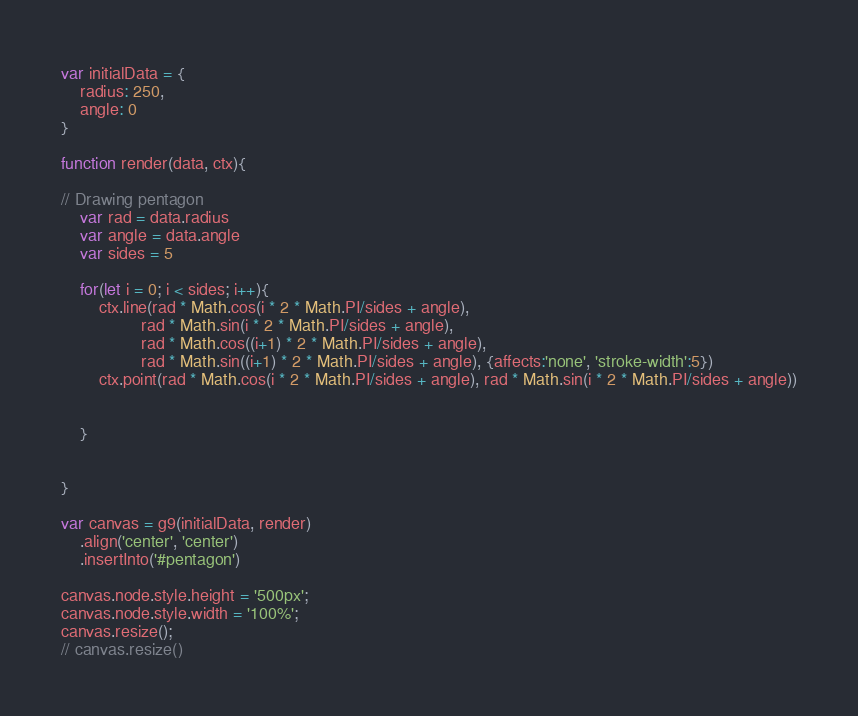Convert code to text. <code><loc_0><loc_0><loc_500><loc_500><_JavaScript_>var initialData = {
    radius: 250,
    angle: 0
}

function render(data, ctx){

// Drawing pentagon
    var rad = data.radius
    var angle = data.angle
    var sides = 5
  
    for(let i = 0; i < sides; i++){
        ctx.line(rad * Math.cos(i * 2 * Math.PI/sides + angle), 
                 rad * Math.sin(i * 2 * Math.PI/sides + angle), 
                 rad * Math.cos((i+1) * 2 * Math.PI/sides + angle), 
                 rad * Math.sin((i+1) * 2 * Math.PI/sides + angle), {affects:'none', 'stroke-width':5})
        ctx.point(rad * Math.cos(i * 2 * Math.PI/sides + angle), rad * Math.sin(i * 2 * Math.PI/sides + angle))


    }


}

var canvas = g9(initialData, render)
    .align('center', 'center')
    .insertInto('#pentagon')

canvas.node.style.height = '500px';
canvas.node.style.width = '100%';
canvas.resize();
// canvas.resize()
</code> 